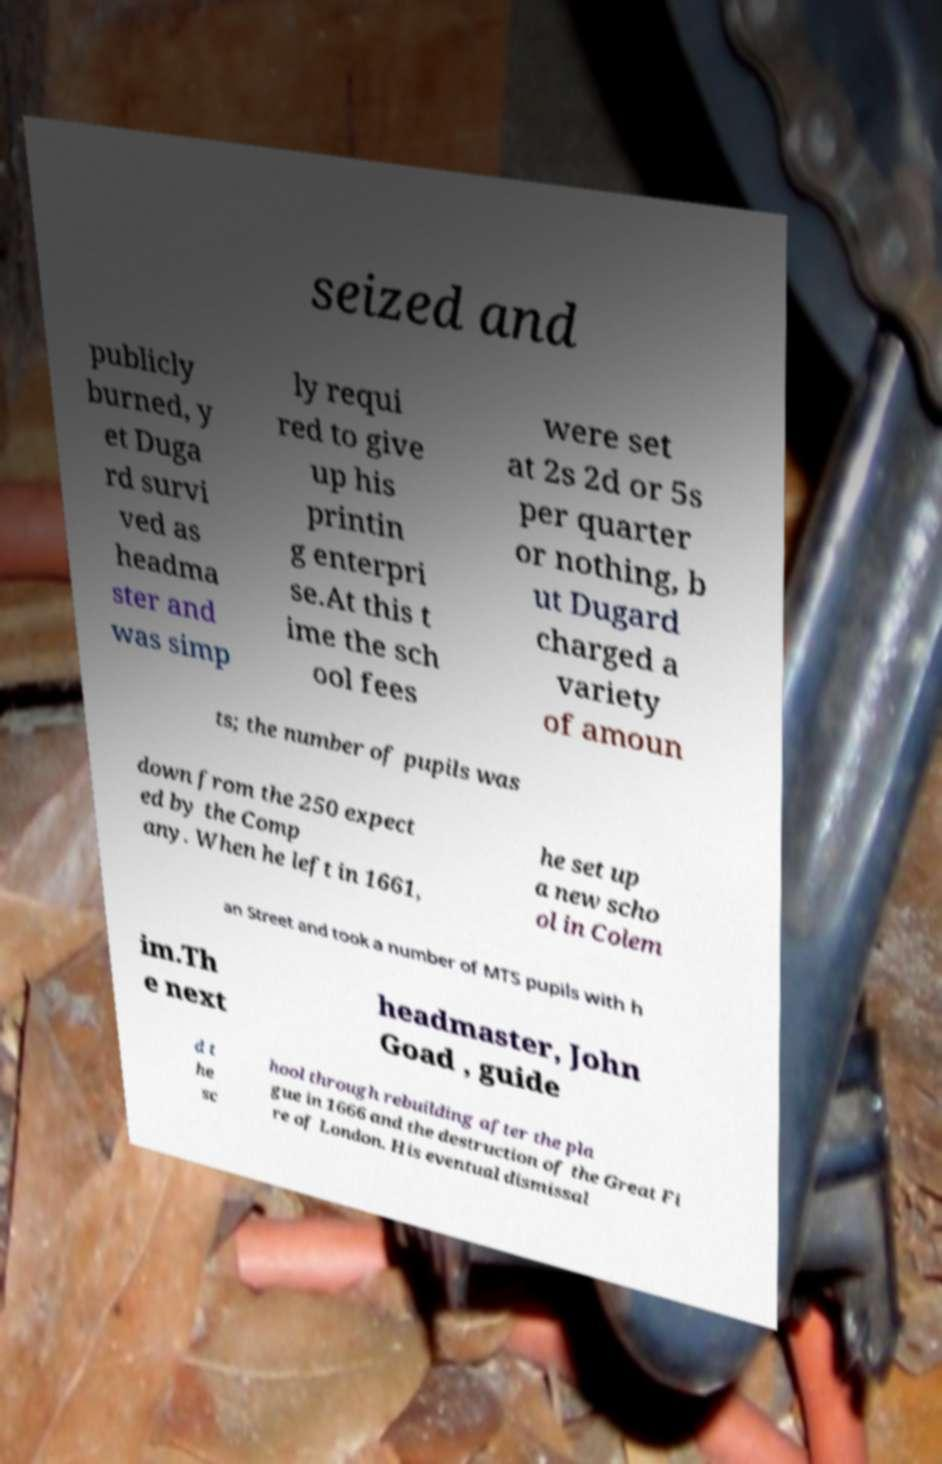I need the written content from this picture converted into text. Can you do that? seized and publicly burned, y et Duga rd survi ved as headma ster and was simp ly requi red to give up his printin g enterpri se.At this t ime the sch ool fees were set at 2s 2d or 5s per quarter or nothing, b ut Dugard charged a variety of amoun ts; the number of pupils was down from the 250 expect ed by the Comp any. When he left in 1661, he set up a new scho ol in Colem an Street and took a number of MTS pupils with h im.Th e next headmaster, John Goad , guide d t he sc hool through rebuilding after the pla gue in 1666 and the destruction of the Great Fi re of London. His eventual dismissal 